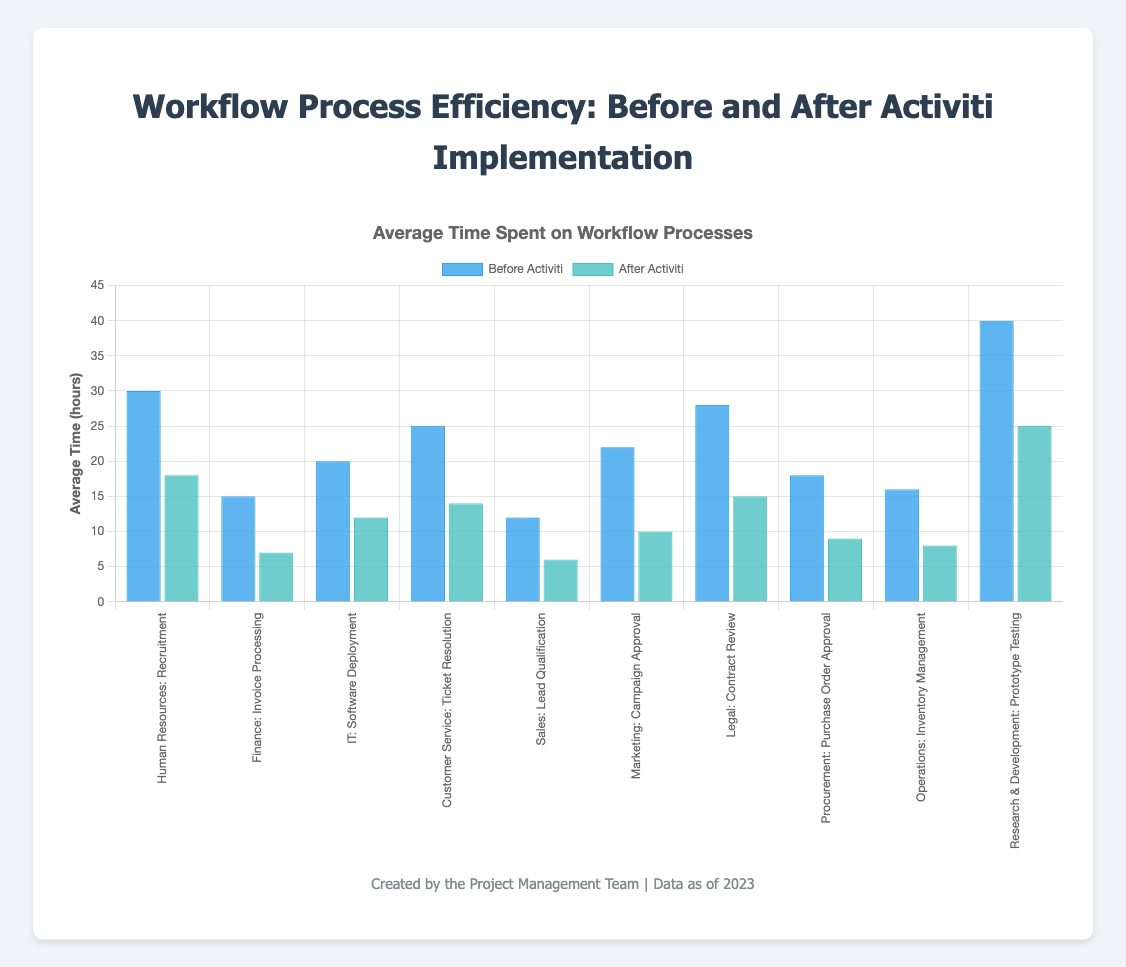Which department showed the greatest reduction in average time spent on workflow processes after Activiti implementation? To find the department with the greatest reduction, calculate the difference between the average times before and after Activiti for each department. The differences are: HR (12), Finance (8), IT (8), Customer Service (11), Sales (6), Marketing (12), Legal (13), Procurement (9), Operations (8), R&D (15). R&D has the greatest reduction of 15 hours.
Answer: Research & Development Which workflow process had the smallest improvement after Activiti implementation? Calculate the differences between the average times before and after Activiti for each process. The smallest difference is observed in the Sales department for the Lead Qualification process, with a reduction of 6 hours.
Answer: Lead Qualification What was the total average time saved across all departments after Activiti implementation? Calculate the total time saved by summing up the differences for each process: HR (12) + Finance (8) + IT (8) + Customer Service (11) + Sales (6) + Marketing (12) + Legal (13) + Procurement (9) + Operations (8) + R&D (15) = 102 hours.
Answer: 102 hours Which workflow process in the IT department was evaluated? Look for the process name under the IT department. It is Software Deployment.
Answer: Software Deployment By how much did the Finance department reduce its average time for Invoice Processing after Activiti implementation? Compare the average time before Activiti (15 hours) with the time after Activiti (7 hours). The reduction is 8 hours.
Answer: 8 hours Which department had an average time after Activiti closest to the average time before Activiti? Compare the "after Activiti" times to the "before Activiti" times and calculate the differences. Legal (28 before - 15 after = 13) is closest among the provided options.
Answer: Legal How many departments managed to reduce their average workflow process time by more than 10 hours? Check each department's time reduction and count those greater than 10: HR (12), Customer Service (11), Marketing (12), Legal (13), and R&D (15). There are 5 departments.
Answer: 5 departments Which department had the highest average time before Activiti implementation? Compare the "before Activiti" times for each department. The R&D department had the highest with 40 hours.
Answer: Research & Development What is the combined average time before Activiti implementation for the HR and Customer Service departments? Add the average times before Activiti for HR (30 hours) and Customer Service (25 hours): 30 + 25 = 55 hours.
Answer: 55 hours 